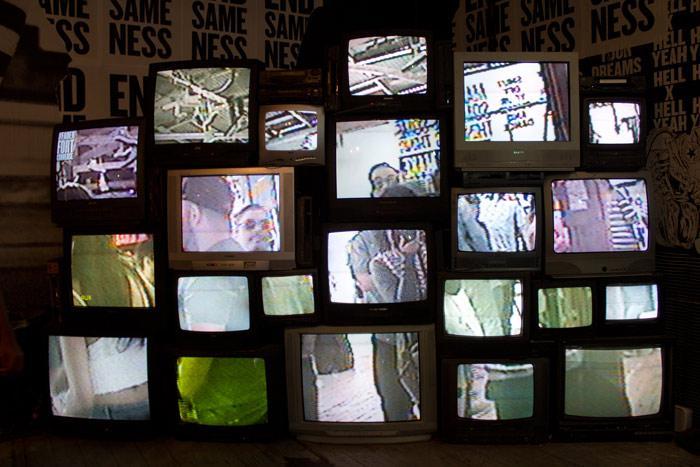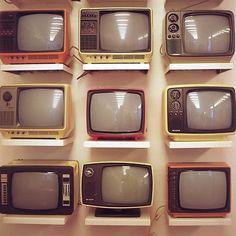The first image is the image on the left, the second image is the image on the right. Examine the images to the left and right. Is the description "There is at least one tv with rainbow stripes on the screen" accurate? Answer yes or no. No. The first image is the image on the left, the second image is the image on the right. Assess this claim about the two images: "The right image shows four stacked rows of same-model TVs, and at least one TV has a gray screen and at least one TV has a rainbow 'test pattern'.". Correct or not? Answer yes or no. No. 